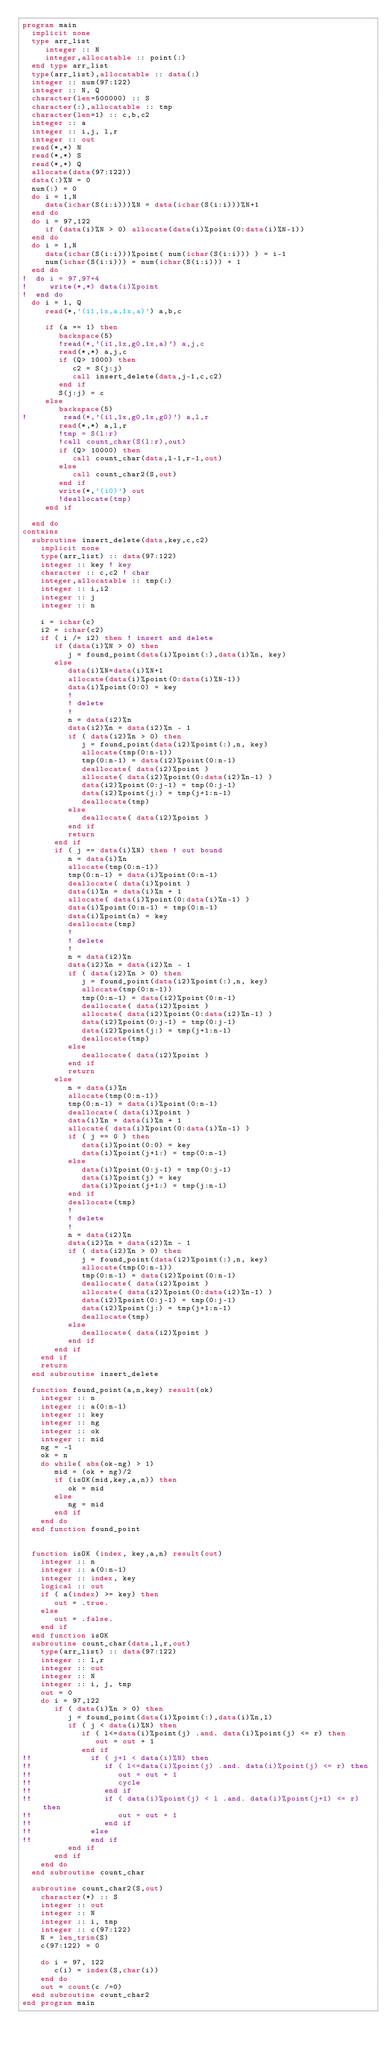Convert code to text. <code><loc_0><loc_0><loc_500><loc_500><_FORTRAN_>program main
  implicit none
  type arr_list
     integer :: N
     integer,allocatable :: point(:)
  end type arr_list
  type(arr_list),allocatable :: data(:)
  integer :: num(97:122)
  integer :: N, Q
  character(len=500000) :: S
  character(:),allocatable :: tmp
  character(len=1) :: c,b,c2
  integer :: a
  integer :: i,j, l,r
  integer :: out
  read(*,*) N
  read(*,*) S
  read(*,*) Q
  allocate(data(97:122))
  data(:)%N = 0
  num(:) = 0
  do i = 1,N
     data(ichar(S(i:i)))%N = data(ichar(S(i:i)))%N+1
  end do
  do i = 97,122
     if (data(i)%N > 0) allocate(data(i)%point(0:data(i)%N-1))
  end do
  do i = 1,N
     data(ichar(S(i:i)))%point( num(ichar(S(i:i))) ) = i-1
     num(ichar(S(i:i))) = num(ichar(S(i:i))) + 1
  end do
!  do i = 97,97+4
!     write(*,*) data(i)%point
!  end do
  do i = 1, Q
     read(*,'(i1,1x,a,1x,a)') a,b,c
     
     if (a == 1) then
        backspace(5)
        !read(*,'(i1,1x,g0,1x,a)') a,j,c
        read(*,*) a,j,c
        if (Q> 1000) then
           c2 = S(j:j)
           call insert_delete(data,j-1,c,c2)
        end if
        S(j:j) = c
     else
        backspace(5)
!        read(*,'(i1,1x,g0,1x,g0)') a,l,r
        read(*,*) a,l,r
        !tmp = S(l:r)
        !call count_char(S(l:r),out)
        if (Q> 10000) then
           call count_char(data,l-1,r-1,out)
        else
           call count_char2(S,out)
        end if
        write(*,'(i0)') out
        !deallocate(tmp)
     end if

  end do
contains
  subroutine insert_delete(data,key,c,c2)
    implicit none
    type(arr_list) :: data(97:122)
    integer :: key ! key
    character :: c,c2 ! char
    integer,allocatable :: tmp(:)
    integer :: i,i2
    integer :: j
    integer :: n

    i = ichar(c)
    i2 = ichar(c2)
    if ( i /= i2) then ! insert and delete
       if (data(i)%N > 0) then
          j = found_point(data(i)%point(:),data(i)%n, key)
       else
          data(i)%N=data(i)%N+1
          allocate(data(i)%point(0:data(i)%N-1))
          data(i)%point(0:0) = key
          !
          ! delete
          !
          n = data(i2)%n
          data(i2)%n = data(i2)%n - 1
          if ( data(i2)%n > 0) then
             j = found_point(data(i2)%point(:),n, key)
             allocate(tmp(0:n-1))
             tmp(0:n-1) = data(i2)%point(0:n-1)
             deallocate( data(i2)%point )
             allocate( data(i2)%point(0:data(i2)%n-1) )
             data(i2)%point(0:j-1) = tmp(0:j-1)
             data(i2)%point(j:) = tmp(j+1:n-1)
             deallocate(tmp)
          else
             deallocate( data(i2)%point )
          end if
          return
       end if
       if ( j == data(i)%N) then ! out bound
          n = data(i)%n
          allocate(tmp(0:n-1))
          tmp(0:n-1) = data(i)%point(0:n-1)
          deallocate( data(i)%point )
          data(i)%n = data(i)%n + 1
          allocate( data(i)%point(0:data(i)%n-1) )
          data(i)%point(0:n-1) = tmp(0:n-1)
          data(i)%point(n) = key
          deallocate(tmp)
          !
          ! delete
          !
          n = data(i2)%n
          data(i2)%n = data(i2)%n - 1
          if ( data(i2)%n > 0) then
             j = found_point(data(i2)%point(:),n, key)
             allocate(tmp(0:n-1))
             tmp(0:n-1) = data(i2)%point(0:n-1)
             deallocate( data(i2)%point )
             allocate( data(i2)%point(0:data(i2)%n-1) )
             data(i2)%point(0:j-1) = tmp(0:j-1)
             data(i2)%point(j:) = tmp(j+1:n-1)
             deallocate(tmp)
          else
             deallocate( data(i2)%point )
          end if
          return
       else
          n = data(i)%n
          allocate(tmp(0:n-1))
          tmp(0:n-1) = data(i)%point(0:n-1)
          deallocate( data(i)%point )
          data(i)%n = data(i)%n + 1
          allocate( data(i)%point(0:data(i)%n-1) )
          if ( j == 0 ) then
             data(i)%point(0:0) = key
             data(i)%point(j+1:) = tmp(0:n-1)
          else 
             data(i)%point(0:j-1) = tmp(0:j-1)
             data(i)%point(j) = key
             data(i)%point(j+1:) = tmp(j:n-1)
          end if
          deallocate(tmp)
          !
          ! delete
          !
          n = data(i2)%n
          data(i2)%n = data(i2)%n - 1
          if ( data(i2)%n > 0) then
             j = found_point(data(i2)%point(:),n, key)
             allocate(tmp(0:n-1))
             tmp(0:n-1) = data(i2)%point(0:n-1)
             deallocate( data(i2)%point )
             allocate( data(i2)%point(0:data(i2)%n-1) )
             data(i2)%point(0:j-1) = tmp(0:j-1)
             data(i2)%point(j:) = tmp(j+1:n-1)
             deallocate(tmp)
          else
             deallocate( data(i2)%point )
          end if
       end if
    end if
    return
  end subroutine insert_delete

  function found_point(a,n,key) result(ok)
    integer :: n
    integer :: a(0:n-1)
    integer :: key
    integer :: ng 
    integer :: ok
    integer :: mid
    ng = -1
    ok = n
    do while( abs(ok-ng) > 1) 
       mid = (ok + ng)/2
       if (isOK(mid,key,a,n)) then
          ok = mid
       else
          ng = mid
       end if
    end do
  end function found_point

  
  function isOK (index, key,a,n) result(out)
    integer :: n
    integer :: a(0:n-1)
    integer :: index, key
    logical :: out
    if ( a(index) >= key) then
       out = .true.
    else 
       out = .false.
    end if
  end function isOK
  subroutine count_char(data,l,r,out)
    type(arr_list) :: data(97:122)
    integer :: l,r
    integer :: out
    integer :: N
    integer :: i, j, tmp
    out = 0
    do i = 97,122
       if ( data(i)%n > 0) then
          j = found_point(data(i)%point(:),data(i)%n,l)
          if ( j < data(i)%N) then
             if ( l<=data(i)%point(j) .and. data(i)%point(j) <= r) then
                out = out + 1
             end if
!!             if ( j+1 < data(i)%N) then
!!                if ( l<=data(i)%point(j) .and. data(i)%point(j) <= r) then
!!                   out = out + 1
!!                   cycle
!!                end if
!!                if ( data(i)%point(j) < l .and. data(i)%point(j+1) <= r) then
!!                   out = out + 1
!!                end if
!!             else
!!             end if
          end if
       end if
    end do
  end subroutine count_char
  
  subroutine count_char2(S,out)
    character(*) :: S
    integer :: out
    integer :: N
    integer :: i, tmp
    integer :: c(97:122)
    N = len_trim(S)
    c(97:122) = 0
    
    do i = 97, 122
       c(i) = index(S,char(i))
    end do
    out = count(c /=0)
  end subroutine count_char2
end program main
</code> 